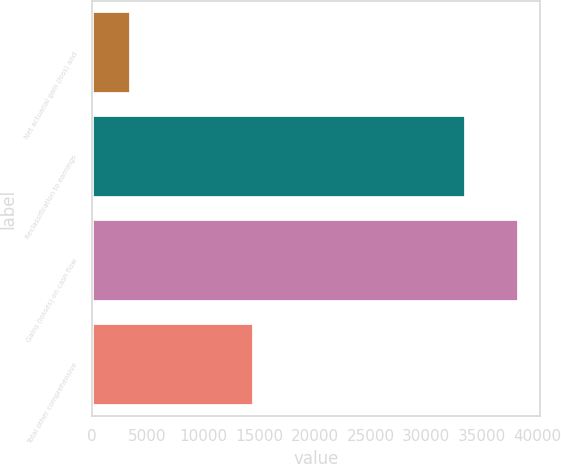Convert chart to OTSL. <chart><loc_0><loc_0><loc_500><loc_500><bar_chart><fcel>Net actuarial gain (loss) and<fcel>Reclassification to earnings<fcel>Gains (losses) on cash flow<fcel>Total other comprehensive<nl><fcel>3557<fcel>33559<fcel>38319<fcel>14604<nl></chart> 